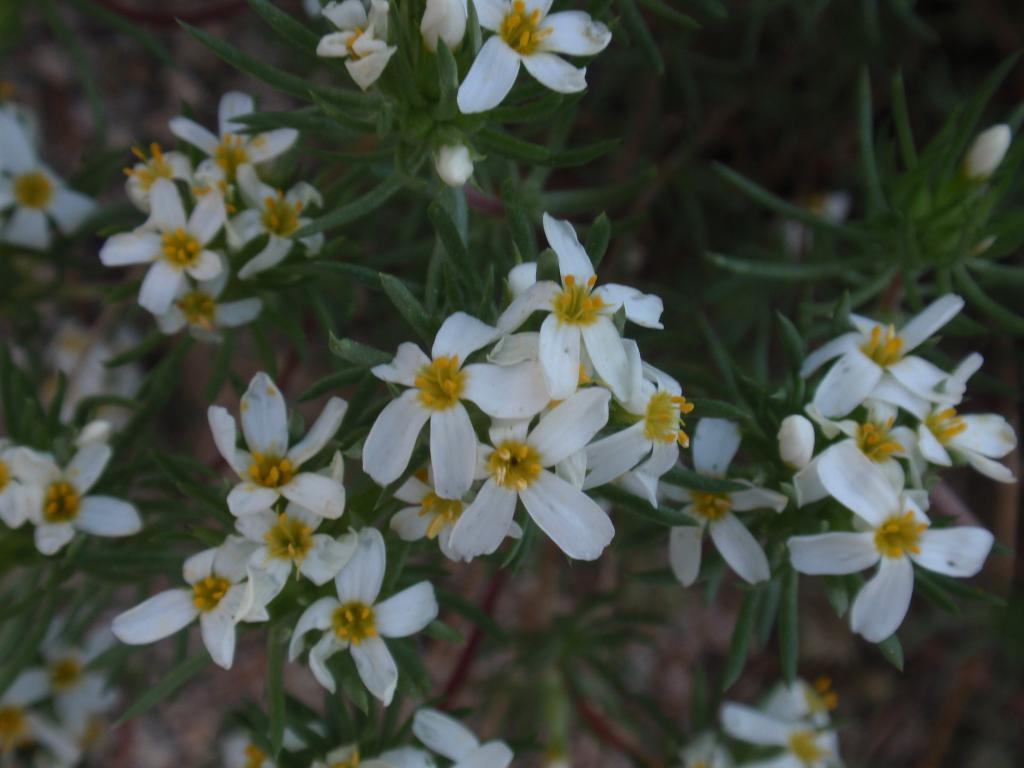What type of living organisms can be seen in the image? Flowers and plants can be seen in the image. Can you describe the colors of the flowers in the image? The colors of the flowers in the image cannot be determined from the provided facts. What is the natural setting visible in the image? The natural setting includes flowers and plants. What type of thrill can be experienced by the flowers in the image? There is no indication in the image that the flowers are experiencing any type of thrill, as flowers do not have the ability to experience emotions or sensations. 